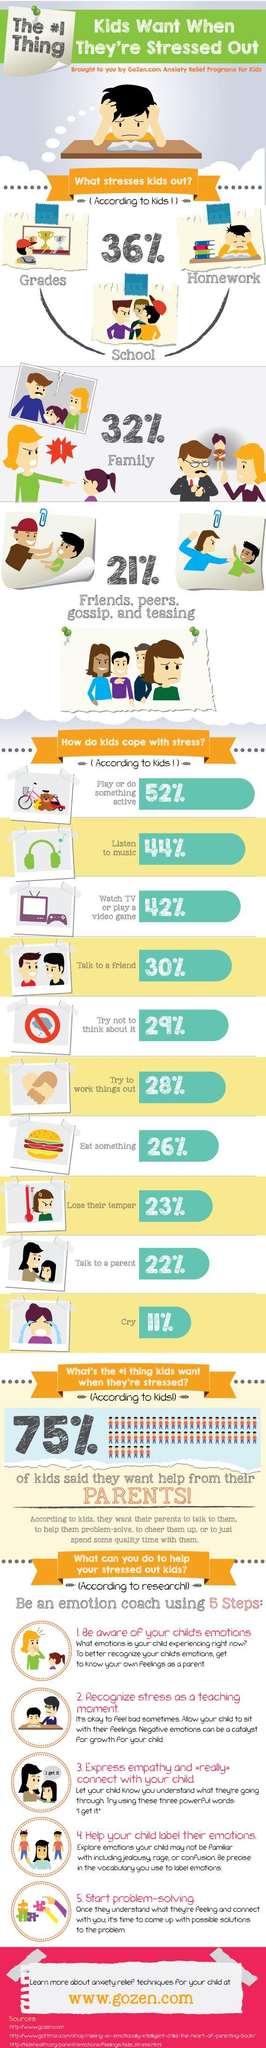What percentage of kids cope with stress without crying?
Answer the question with a short phrase. 89% What percentage of kids cope with stress without talking to a parent? 78% What percentage of kids cope with stress without talking to a friend? 70% What percentage of kids cope with stress without watching the tv? 58% What percentage of kids cope with stress without listening to music? 56% 